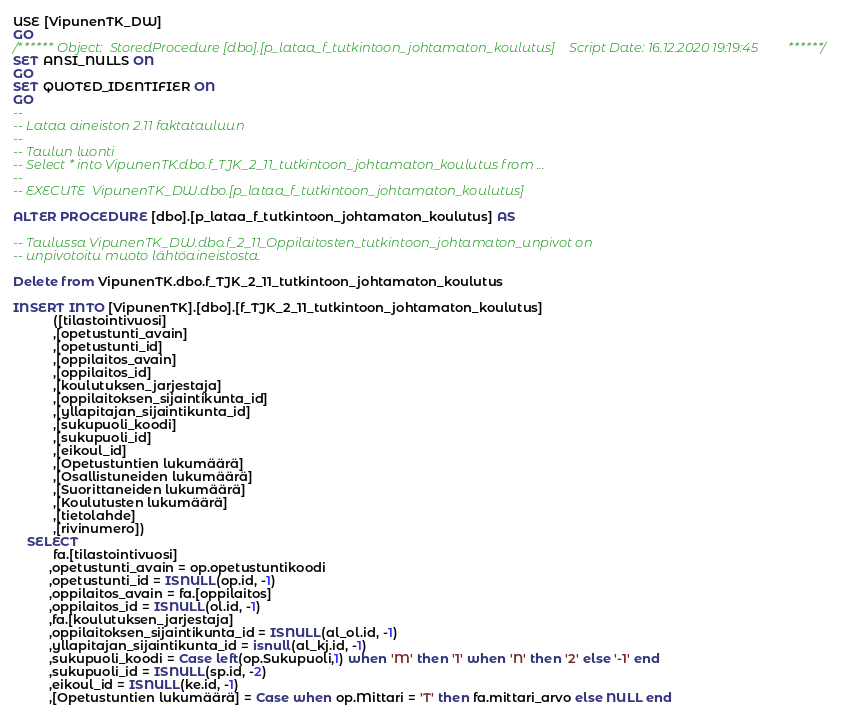<code> <loc_0><loc_0><loc_500><loc_500><_SQL_>USE [VipunenTK_DW]
GO
/****** Object:  StoredProcedure [dbo].[p_lataa_f_tutkintoon_johtamaton_koulutus]    Script Date: 16.12.2020 19:19:45 ******/
SET ANSI_NULLS ON
GO
SET QUOTED_IDENTIFIER ON
GO
--
-- Lataa aineiston 2.11 faktatauluun 
--
-- Taulun luonti
-- Select * into VipunenTK.dbo.f_TJK_2_11_tutkintoon_johtamaton_koulutus from ...
--
-- EXECUTE  VipunenTK_DW.dbo.[p_lataa_f_tutkintoon_johtamaton_koulutus]

ALTER PROCEDURE [dbo].[p_lataa_f_tutkintoon_johtamaton_koulutus] AS

-- Taulussa VipunenTK_DW.dbo.f_2_11_Oppilaitosten_tutkintoon_johtamaton_unpivot on
-- unpivotoitu muoto lähtöaineistosta.

Delete from VipunenTK.dbo.f_TJK_2_11_tutkintoon_johtamaton_koulutus

INSERT INTO [VipunenTK].[dbo].[f_TJK_2_11_tutkintoon_johtamaton_koulutus]
           ([tilastointivuosi]
           ,[opetustunti_avain]
           ,[opetustunti_id]
           ,[oppilaitos_avain]
           ,[oppilaitos_id]
           ,[koulutuksen_jarjestaja]
           ,[oppilaitoksen_sijaintikunta_id]
           ,[yllapitajan_sijaintikunta_id]
           ,[sukupuoli_koodi]
           ,[sukupuoli_id]
		   ,[eikoul_id]
           ,[Opetustuntien lukumäärä]
           ,[Osallistuneiden lukumäärä]
           ,[Suorittaneiden lukumäärä]
           ,[Koulutusten lukumäärä]
           ,[tietolahde]
           ,[rivinumero])
	SELECT
		   fa.[tilastointivuosi]
		  ,opetustunti_avain = op.opetustuntikoodi
		  ,opetustunti_id = ISNULL(op.id, -1)
		  ,oppilaitos_avain = fa.[oppilaitos]
		  ,oppilaitos_id = ISNULL(ol.id, -1)
		  ,fa.[koulutuksen_jarjestaja]
		  ,oppilaitoksen_sijaintikunta_id = ISNULL(al_ol.id, -1)
		  ,yllapitajan_sijaintikunta_id = isnull(al_kj.id, -1)
		  ,sukupuoli_koodi = Case left(op.Sukupuoli,1) when 'M' then '1' when 'N' then '2' else '-1' end
		  ,sukupuoli_id = ISNULL(sp.id, -2)
		  ,eikoul_id = ISNULL(ke.id, -1)
		  ,[Opetustuntien lukumäärä] = Case when op.Mittari = 'T' then fa.mittari_arvo else NULL end</code> 